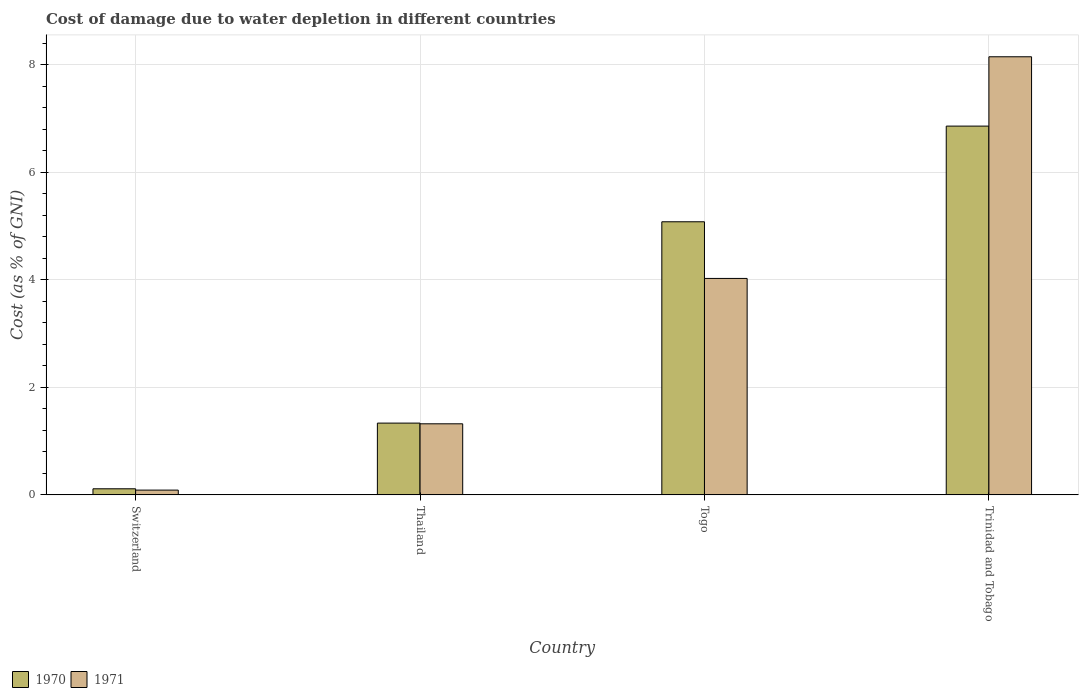How many different coloured bars are there?
Offer a very short reply. 2. Are the number of bars per tick equal to the number of legend labels?
Offer a very short reply. Yes. Are the number of bars on each tick of the X-axis equal?
Keep it short and to the point. Yes. How many bars are there on the 3rd tick from the left?
Ensure brevity in your answer.  2. What is the label of the 4th group of bars from the left?
Provide a succinct answer. Trinidad and Tobago. What is the cost of damage caused due to water depletion in 1971 in Thailand?
Ensure brevity in your answer.  1.32. Across all countries, what is the maximum cost of damage caused due to water depletion in 1970?
Your answer should be compact. 6.86. Across all countries, what is the minimum cost of damage caused due to water depletion in 1970?
Your answer should be compact. 0.11. In which country was the cost of damage caused due to water depletion in 1970 maximum?
Provide a succinct answer. Trinidad and Tobago. In which country was the cost of damage caused due to water depletion in 1971 minimum?
Give a very brief answer. Switzerland. What is the total cost of damage caused due to water depletion in 1970 in the graph?
Keep it short and to the point. 13.38. What is the difference between the cost of damage caused due to water depletion in 1971 in Switzerland and that in Togo?
Keep it short and to the point. -3.93. What is the difference between the cost of damage caused due to water depletion in 1970 in Thailand and the cost of damage caused due to water depletion in 1971 in Trinidad and Tobago?
Your response must be concise. -6.81. What is the average cost of damage caused due to water depletion in 1970 per country?
Your answer should be compact. 3.35. What is the difference between the cost of damage caused due to water depletion of/in 1970 and cost of damage caused due to water depletion of/in 1971 in Trinidad and Tobago?
Ensure brevity in your answer.  -1.29. What is the ratio of the cost of damage caused due to water depletion in 1971 in Switzerland to that in Togo?
Provide a short and direct response. 0.02. Is the cost of damage caused due to water depletion in 1971 in Thailand less than that in Trinidad and Tobago?
Ensure brevity in your answer.  Yes. What is the difference between the highest and the second highest cost of damage caused due to water depletion in 1970?
Provide a succinct answer. -3.74. What is the difference between the highest and the lowest cost of damage caused due to water depletion in 1971?
Give a very brief answer. 8.05. Are all the bars in the graph horizontal?
Your answer should be very brief. No. What is the difference between two consecutive major ticks on the Y-axis?
Your answer should be compact. 2. Are the values on the major ticks of Y-axis written in scientific E-notation?
Provide a succinct answer. No. Does the graph contain any zero values?
Make the answer very short. No. Does the graph contain grids?
Make the answer very short. Yes. How are the legend labels stacked?
Provide a succinct answer. Horizontal. What is the title of the graph?
Give a very brief answer. Cost of damage due to water depletion in different countries. Does "1979" appear as one of the legend labels in the graph?
Offer a very short reply. No. What is the label or title of the X-axis?
Offer a very short reply. Country. What is the label or title of the Y-axis?
Make the answer very short. Cost (as % of GNI). What is the Cost (as % of GNI) of 1970 in Switzerland?
Provide a short and direct response. 0.11. What is the Cost (as % of GNI) in 1971 in Switzerland?
Your response must be concise. 0.09. What is the Cost (as % of GNI) in 1970 in Thailand?
Your answer should be very brief. 1.33. What is the Cost (as % of GNI) of 1971 in Thailand?
Give a very brief answer. 1.32. What is the Cost (as % of GNI) in 1970 in Togo?
Give a very brief answer. 5.08. What is the Cost (as % of GNI) in 1971 in Togo?
Provide a short and direct response. 4.02. What is the Cost (as % of GNI) in 1970 in Trinidad and Tobago?
Provide a succinct answer. 6.86. What is the Cost (as % of GNI) of 1971 in Trinidad and Tobago?
Make the answer very short. 8.14. Across all countries, what is the maximum Cost (as % of GNI) in 1970?
Keep it short and to the point. 6.86. Across all countries, what is the maximum Cost (as % of GNI) of 1971?
Provide a succinct answer. 8.14. Across all countries, what is the minimum Cost (as % of GNI) of 1970?
Your response must be concise. 0.11. Across all countries, what is the minimum Cost (as % of GNI) in 1971?
Provide a short and direct response. 0.09. What is the total Cost (as % of GNI) in 1970 in the graph?
Offer a terse response. 13.38. What is the total Cost (as % of GNI) in 1971 in the graph?
Give a very brief answer. 13.58. What is the difference between the Cost (as % of GNI) of 1970 in Switzerland and that in Thailand?
Keep it short and to the point. -1.22. What is the difference between the Cost (as % of GNI) of 1971 in Switzerland and that in Thailand?
Offer a terse response. -1.23. What is the difference between the Cost (as % of GNI) of 1970 in Switzerland and that in Togo?
Your response must be concise. -4.96. What is the difference between the Cost (as % of GNI) in 1971 in Switzerland and that in Togo?
Make the answer very short. -3.93. What is the difference between the Cost (as % of GNI) of 1970 in Switzerland and that in Trinidad and Tobago?
Keep it short and to the point. -6.74. What is the difference between the Cost (as % of GNI) in 1971 in Switzerland and that in Trinidad and Tobago?
Ensure brevity in your answer.  -8.05. What is the difference between the Cost (as % of GNI) of 1970 in Thailand and that in Togo?
Offer a terse response. -3.74. What is the difference between the Cost (as % of GNI) of 1971 in Thailand and that in Togo?
Provide a short and direct response. -2.7. What is the difference between the Cost (as % of GNI) of 1970 in Thailand and that in Trinidad and Tobago?
Offer a terse response. -5.52. What is the difference between the Cost (as % of GNI) in 1971 in Thailand and that in Trinidad and Tobago?
Provide a short and direct response. -6.82. What is the difference between the Cost (as % of GNI) of 1970 in Togo and that in Trinidad and Tobago?
Provide a succinct answer. -1.78. What is the difference between the Cost (as % of GNI) in 1971 in Togo and that in Trinidad and Tobago?
Keep it short and to the point. -4.12. What is the difference between the Cost (as % of GNI) of 1970 in Switzerland and the Cost (as % of GNI) of 1971 in Thailand?
Your answer should be compact. -1.21. What is the difference between the Cost (as % of GNI) in 1970 in Switzerland and the Cost (as % of GNI) in 1971 in Togo?
Offer a terse response. -3.91. What is the difference between the Cost (as % of GNI) in 1970 in Switzerland and the Cost (as % of GNI) in 1971 in Trinidad and Tobago?
Your answer should be very brief. -8.03. What is the difference between the Cost (as % of GNI) in 1970 in Thailand and the Cost (as % of GNI) in 1971 in Togo?
Offer a very short reply. -2.69. What is the difference between the Cost (as % of GNI) in 1970 in Thailand and the Cost (as % of GNI) in 1971 in Trinidad and Tobago?
Keep it short and to the point. -6.81. What is the difference between the Cost (as % of GNI) in 1970 in Togo and the Cost (as % of GNI) in 1971 in Trinidad and Tobago?
Keep it short and to the point. -3.07. What is the average Cost (as % of GNI) in 1970 per country?
Your response must be concise. 3.35. What is the average Cost (as % of GNI) of 1971 per country?
Offer a terse response. 3.39. What is the difference between the Cost (as % of GNI) in 1970 and Cost (as % of GNI) in 1971 in Switzerland?
Offer a terse response. 0.02. What is the difference between the Cost (as % of GNI) of 1970 and Cost (as % of GNI) of 1971 in Thailand?
Your response must be concise. 0.01. What is the difference between the Cost (as % of GNI) of 1970 and Cost (as % of GNI) of 1971 in Togo?
Provide a short and direct response. 1.05. What is the difference between the Cost (as % of GNI) in 1970 and Cost (as % of GNI) in 1971 in Trinidad and Tobago?
Offer a very short reply. -1.29. What is the ratio of the Cost (as % of GNI) of 1970 in Switzerland to that in Thailand?
Keep it short and to the point. 0.09. What is the ratio of the Cost (as % of GNI) in 1971 in Switzerland to that in Thailand?
Your answer should be very brief. 0.07. What is the ratio of the Cost (as % of GNI) of 1970 in Switzerland to that in Togo?
Your response must be concise. 0.02. What is the ratio of the Cost (as % of GNI) in 1971 in Switzerland to that in Togo?
Your answer should be compact. 0.02. What is the ratio of the Cost (as % of GNI) in 1970 in Switzerland to that in Trinidad and Tobago?
Offer a very short reply. 0.02. What is the ratio of the Cost (as % of GNI) of 1971 in Switzerland to that in Trinidad and Tobago?
Your answer should be compact. 0.01. What is the ratio of the Cost (as % of GNI) of 1970 in Thailand to that in Togo?
Your answer should be very brief. 0.26. What is the ratio of the Cost (as % of GNI) in 1971 in Thailand to that in Togo?
Give a very brief answer. 0.33. What is the ratio of the Cost (as % of GNI) in 1970 in Thailand to that in Trinidad and Tobago?
Ensure brevity in your answer.  0.19. What is the ratio of the Cost (as % of GNI) of 1971 in Thailand to that in Trinidad and Tobago?
Offer a very short reply. 0.16. What is the ratio of the Cost (as % of GNI) of 1970 in Togo to that in Trinidad and Tobago?
Make the answer very short. 0.74. What is the ratio of the Cost (as % of GNI) in 1971 in Togo to that in Trinidad and Tobago?
Ensure brevity in your answer.  0.49. What is the difference between the highest and the second highest Cost (as % of GNI) in 1970?
Ensure brevity in your answer.  1.78. What is the difference between the highest and the second highest Cost (as % of GNI) in 1971?
Provide a succinct answer. 4.12. What is the difference between the highest and the lowest Cost (as % of GNI) in 1970?
Provide a short and direct response. 6.74. What is the difference between the highest and the lowest Cost (as % of GNI) of 1971?
Provide a short and direct response. 8.05. 